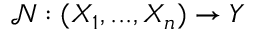Convert formula to latex. <formula><loc_0><loc_0><loc_500><loc_500>\mathcal { N } \colon ( X _ { 1 } , \dots , X _ { n } ) \rightarrow Y</formula> 